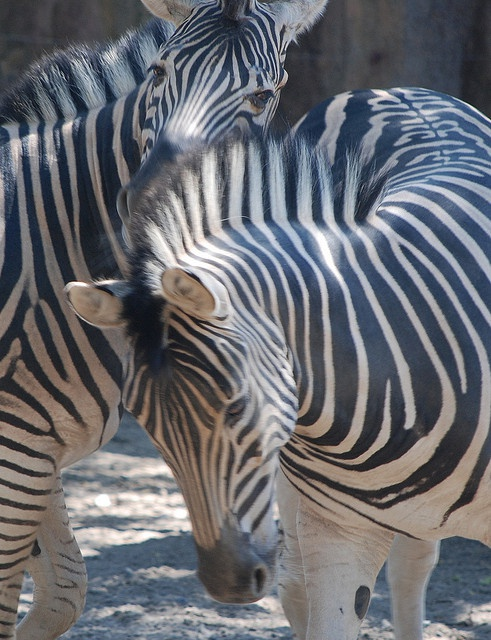Describe the objects in this image and their specific colors. I can see zebra in black, darkgray, gray, and darkblue tones and zebra in black, gray, and darkgray tones in this image. 